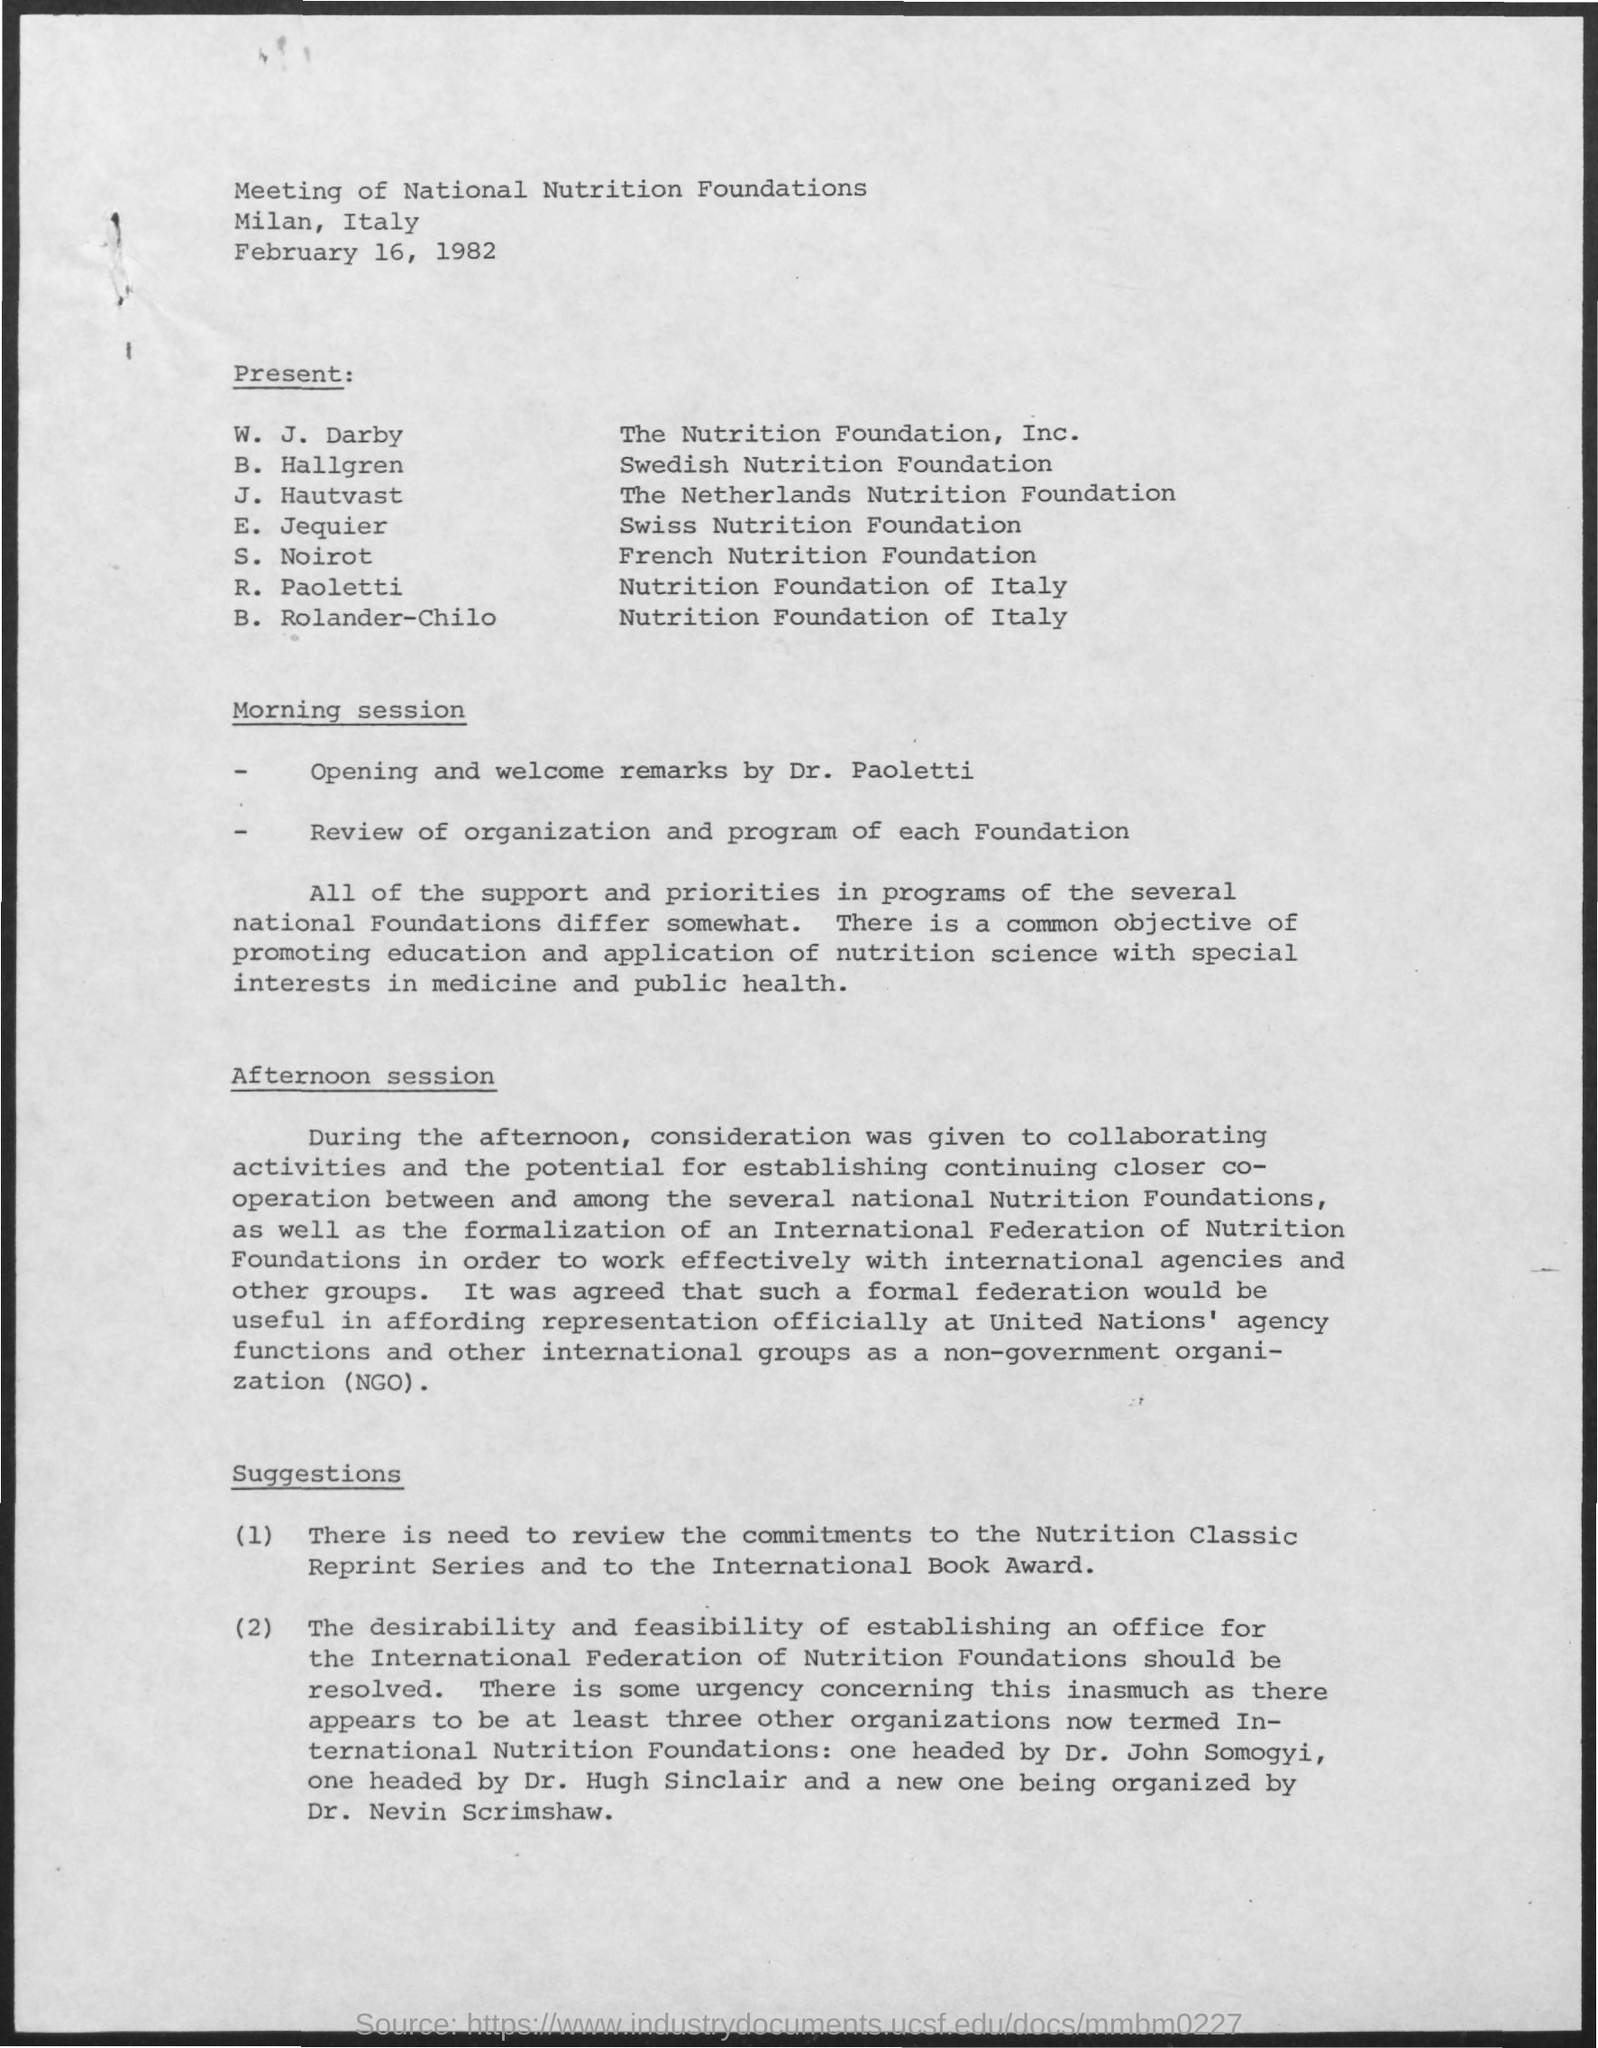Where was the meeting conducted ?
Your answer should be compact. Milan , Italy. On which date the meeting was scheduled ?
Your answer should be compact. February 16, 1982. B. Hallgren belongs to which foundation ?
Provide a short and direct response. Swedish Nutrition Foundation. S. Noirot belongs to which foundation ?
Your answer should be compact. French Nutrition Foundation. J. Hautvast belongs to which foundation ?
Your response must be concise. The Netherlands nutrition foundation. 